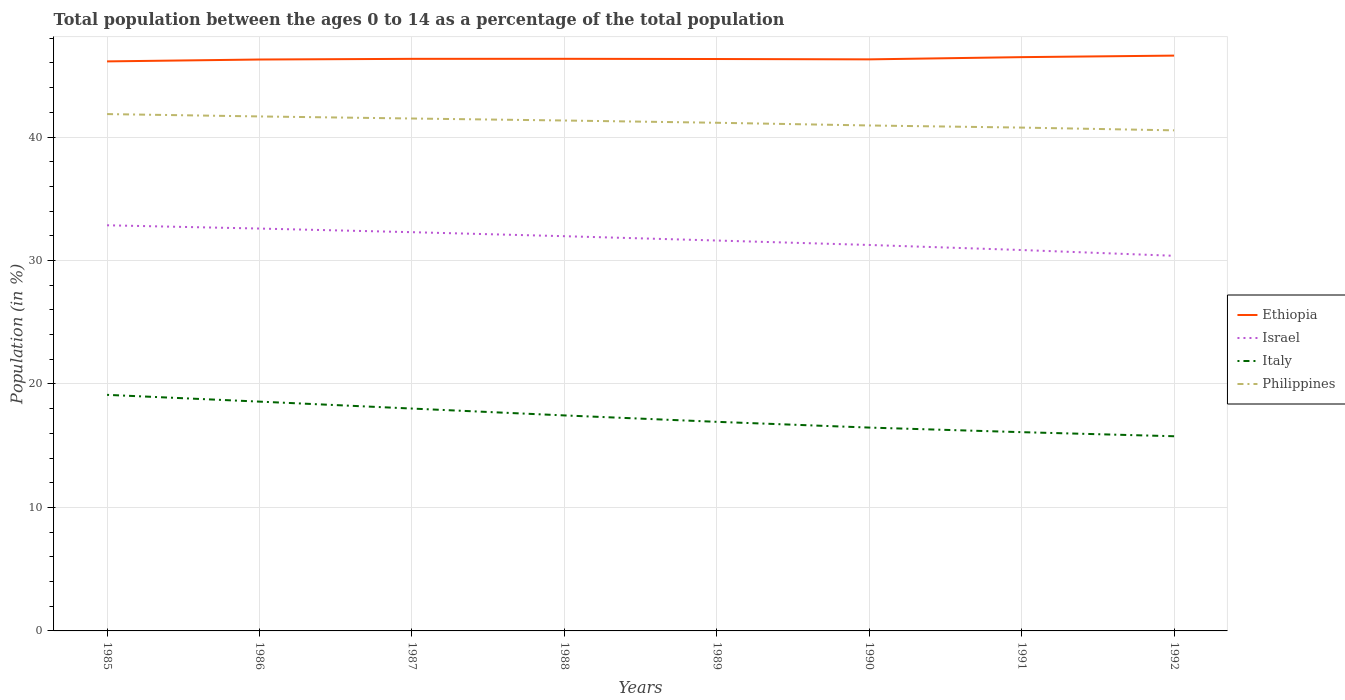Is the number of lines equal to the number of legend labels?
Keep it short and to the point. Yes. Across all years, what is the maximum percentage of the population ages 0 to 14 in Philippines?
Offer a terse response. 40.54. In which year was the percentage of the population ages 0 to 14 in Philippines maximum?
Give a very brief answer. 1992. What is the total percentage of the population ages 0 to 14 in Italy in the graph?
Provide a short and direct response. 2.1. What is the difference between the highest and the second highest percentage of the population ages 0 to 14 in Italy?
Provide a succinct answer. 3.35. What is the difference between the highest and the lowest percentage of the population ages 0 to 14 in Italy?
Provide a short and direct response. 4. How many lines are there?
Your answer should be compact. 4. Are the values on the major ticks of Y-axis written in scientific E-notation?
Your answer should be very brief. No. What is the title of the graph?
Offer a very short reply. Total population between the ages 0 to 14 as a percentage of the total population. Does "High income: OECD" appear as one of the legend labels in the graph?
Your answer should be very brief. No. What is the Population (in %) of Ethiopia in 1985?
Keep it short and to the point. 46.13. What is the Population (in %) in Israel in 1985?
Your response must be concise. 32.85. What is the Population (in %) of Italy in 1985?
Provide a short and direct response. 19.12. What is the Population (in %) of Philippines in 1985?
Provide a short and direct response. 41.86. What is the Population (in %) in Ethiopia in 1986?
Make the answer very short. 46.28. What is the Population (in %) in Israel in 1986?
Ensure brevity in your answer.  32.59. What is the Population (in %) of Italy in 1986?
Give a very brief answer. 18.57. What is the Population (in %) of Philippines in 1986?
Offer a terse response. 41.67. What is the Population (in %) in Ethiopia in 1987?
Your answer should be very brief. 46.34. What is the Population (in %) of Israel in 1987?
Provide a succinct answer. 32.3. What is the Population (in %) of Italy in 1987?
Your answer should be very brief. 18.01. What is the Population (in %) of Philippines in 1987?
Ensure brevity in your answer.  41.5. What is the Population (in %) in Ethiopia in 1988?
Keep it short and to the point. 46.34. What is the Population (in %) of Israel in 1988?
Your response must be concise. 31.97. What is the Population (in %) in Italy in 1988?
Your answer should be very brief. 17.45. What is the Population (in %) in Philippines in 1988?
Provide a succinct answer. 41.34. What is the Population (in %) in Ethiopia in 1989?
Provide a succinct answer. 46.32. What is the Population (in %) of Israel in 1989?
Offer a terse response. 31.62. What is the Population (in %) of Italy in 1989?
Your response must be concise. 16.94. What is the Population (in %) in Philippines in 1989?
Provide a short and direct response. 41.16. What is the Population (in %) in Ethiopia in 1990?
Offer a very short reply. 46.29. What is the Population (in %) of Israel in 1990?
Offer a terse response. 31.26. What is the Population (in %) of Italy in 1990?
Keep it short and to the point. 16.47. What is the Population (in %) in Philippines in 1990?
Your response must be concise. 40.94. What is the Population (in %) of Ethiopia in 1991?
Your answer should be compact. 46.47. What is the Population (in %) of Israel in 1991?
Keep it short and to the point. 30.85. What is the Population (in %) in Italy in 1991?
Ensure brevity in your answer.  16.1. What is the Population (in %) of Philippines in 1991?
Your response must be concise. 40.77. What is the Population (in %) of Ethiopia in 1992?
Provide a succinct answer. 46.6. What is the Population (in %) in Israel in 1992?
Provide a short and direct response. 30.38. What is the Population (in %) in Italy in 1992?
Offer a very short reply. 15.77. What is the Population (in %) in Philippines in 1992?
Give a very brief answer. 40.54. Across all years, what is the maximum Population (in %) in Ethiopia?
Provide a short and direct response. 46.6. Across all years, what is the maximum Population (in %) of Israel?
Give a very brief answer. 32.85. Across all years, what is the maximum Population (in %) of Italy?
Offer a very short reply. 19.12. Across all years, what is the maximum Population (in %) in Philippines?
Provide a succinct answer. 41.86. Across all years, what is the minimum Population (in %) in Ethiopia?
Your answer should be compact. 46.13. Across all years, what is the minimum Population (in %) in Israel?
Provide a succinct answer. 30.38. Across all years, what is the minimum Population (in %) of Italy?
Your answer should be very brief. 15.77. Across all years, what is the minimum Population (in %) of Philippines?
Your answer should be very brief. 40.54. What is the total Population (in %) of Ethiopia in the graph?
Provide a succinct answer. 370.77. What is the total Population (in %) of Israel in the graph?
Provide a succinct answer. 253.83. What is the total Population (in %) in Italy in the graph?
Provide a succinct answer. 138.43. What is the total Population (in %) of Philippines in the graph?
Provide a short and direct response. 329.79. What is the difference between the Population (in %) of Ethiopia in 1985 and that in 1986?
Ensure brevity in your answer.  -0.15. What is the difference between the Population (in %) in Israel in 1985 and that in 1986?
Ensure brevity in your answer.  0.27. What is the difference between the Population (in %) of Italy in 1985 and that in 1986?
Provide a short and direct response. 0.55. What is the difference between the Population (in %) of Philippines in 1985 and that in 1986?
Your answer should be compact. 0.19. What is the difference between the Population (in %) in Ethiopia in 1985 and that in 1987?
Your answer should be compact. -0.21. What is the difference between the Population (in %) of Israel in 1985 and that in 1987?
Your answer should be compact. 0.56. What is the difference between the Population (in %) in Italy in 1985 and that in 1987?
Give a very brief answer. 1.11. What is the difference between the Population (in %) of Philippines in 1985 and that in 1987?
Your answer should be compact. 0.36. What is the difference between the Population (in %) in Ethiopia in 1985 and that in 1988?
Your answer should be compact. -0.21. What is the difference between the Population (in %) in Israel in 1985 and that in 1988?
Your answer should be compact. 0.88. What is the difference between the Population (in %) of Italy in 1985 and that in 1988?
Provide a succinct answer. 1.67. What is the difference between the Population (in %) of Philippines in 1985 and that in 1988?
Your answer should be very brief. 0.52. What is the difference between the Population (in %) in Ethiopia in 1985 and that in 1989?
Keep it short and to the point. -0.19. What is the difference between the Population (in %) in Israel in 1985 and that in 1989?
Offer a very short reply. 1.23. What is the difference between the Population (in %) of Italy in 1985 and that in 1989?
Provide a short and direct response. 2.19. What is the difference between the Population (in %) in Philippines in 1985 and that in 1989?
Keep it short and to the point. 0.7. What is the difference between the Population (in %) of Ethiopia in 1985 and that in 1990?
Your response must be concise. -0.16. What is the difference between the Population (in %) of Israel in 1985 and that in 1990?
Give a very brief answer. 1.59. What is the difference between the Population (in %) in Italy in 1985 and that in 1990?
Make the answer very short. 2.65. What is the difference between the Population (in %) in Philippines in 1985 and that in 1990?
Ensure brevity in your answer.  0.92. What is the difference between the Population (in %) of Ethiopia in 1985 and that in 1991?
Make the answer very short. -0.34. What is the difference between the Population (in %) of Israel in 1985 and that in 1991?
Keep it short and to the point. 2. What is the difference between the Population (in %) in Italy in 1985 and that in 1991?
Your answer should be very brief. 3.02. What is the difference between the Population (in %) of Philippines in 1985 and that in 1991?
Your response must be concise. 1.09. What is the difference between the Population (in %) in Ethiopia in 1985 and that in 1992?
Ensure brevity in your answer.  -0.47. What is the difference between the Population (in %) in Israel in 1985 and that in 1992?
Keep it short and to the point. 2.47. What is the difference between the Population (in %) in Italy in 1985 and that in 1992?
Ensure brevity in your answer.  3.35. What is the difference between the Population (in %) of Philippines in 1985 and that in 1992?
Provide a short and direct response. 1.32. What is the difference between the Population (in %) of Ethiopia in 1986 and that in 1987?
Your answer should be very brief. -0.05. What is the difference between the Population (in %) of Israel in 1986 and that in 1987?
Offer a very short reply. 0.29. What is the difference between the Population (in %) in Italy in 1986 and that in 1987?
Offer a terse response. 0.56. What is the difference between the Population (in %) of Philippines in 1986 and that in 1987?
Your answer should be compact. 0.17. What is the difference between the Population (in %) in Ethiopia in 1986 and that in 1988?
Give a very brief answer. -0.06. What is the difference between the Population (in %) in Israel in 1986 and that in 1988?
Provide a succinct answer. 0.62. What is the difference between the Population (in %) of Italy in 1986 and that in 1988?
Make the answer very short. 1.12. What is the difference between the Population (in %) of Philippines in 1986 and that in 1988?
Your response must be concise. 0.33. What is the difference between the Population (in %) of Ethiopia in 1986 and that in 1989?
Provide a succinct answer. -0.04. What is the difference between the Population (in %) of Israel in 1986 and that in 1989?
Keep it short and to the point. 0.97. What is the difference between the Population (in %) in Italy in 1986 and that in 1989?
Make the answer very short. 1.64. What is the difference between the Population (in %) of Philippines in 1986 and that in 1989?
Your answer should be compact. 0.51. What is the difference between the Population (in %) in Ethiopia in 1986 and that in 1990?
Your answer should be compact. -0.01. What is the difference between the Population (in %) of Israel in 1986 and that in 1990?
Provide a short and direct response. 1.33. What is the difference between the Population (in %) of Italy in 1986 and that in 1990?
Make the answer very short. 2.1. What is the difference between the Population (in %) in Philippines in 1986 and that in 1990?
Your answer should be compact. 0.73. What is the difference between the Population (in %) in Ethiopia in 1986 and that in 1991?
Your response must be concise. -0.19. What is the difference between the Population (in %) in Israel in 1986 and that in 1991?
Offer a terse response. 1.74. What is the difference between the Population (in %) of Italy in 1986 and that in 1991?
Offer a very short reply. 2.47. What is the difference between the Population (in %) of Philippines in 1986 and that in 1991?
Provide a short and direct response. 0.9. What is the difference between the Population (in %) in Ethiopia in 1986 and that in 1992?
Your answer should be very brief. -0.32. What is the difference between the Population (in %) of Israel in 1986 and that in 1992?
Your response must be concise. 2.21. What is the difference between the Population (in %) of Italy in 1986 and that in 1992?
Your answer should be very brief. 2.8. What is the difference between the Population (in %) of Philippines in 1986 and that in 1992?
Your response must be concise. 1.13. What is the difference between the Population (in %) in Ethiopia in 1987 and that in 1988?
Offer a very short reply. -0. What is the difference between the Population (in %) in Israel in 1987 and that in 1988?
Make the answer very short. 0.33. What is the difference between the Population (in %) in Italy in 1987 and that in 1988?
Ensure brevity in your answer.  0.56. What is the difference between the Population (in %) in Philippines in 1987 and that in 1988?
Provide a succinct answer. 0.16. What is the difference between the Population (in %) of Ethiopia in 1987 and that in 1989?
Offer a terse response. 0.01. What is the difference between the Population (in %) in Israel in 1987 and that in 1989?
Your answer should be very brief. 0.68. What is the difference between the Population (in %) in Italy in 1987 and that in 1989?
Keep it short and to the point. 1.07. What is the difference between the Population (in %) of Philippines in 1987 and that in 1989?
Offer a terse response. 0.34. What is the difference between the Population (in %) of Ethiopia in 1987 and that in 1990?
Provide a short and direct response. 0.04. What is the difference between the Population (in %) of Israel in 1987 and that in 1990?
Your answer should be compact. 1.04. What is the difference between the Population (in %) of Italy in 1987 and that in 1990?
Keep it short and to the point. 1.54. What is the difference between the Population (in %) of Philippines in 1987 and that in 1990?
Ensure brevity in your answer.  0.56. What is the difference between the Population (in %) in Ethiopia in 1987 and that in 1991?
Provide a succinct answer. -0.14. What is the difference between the Population (in %) in Israel in 1987 and that in 1991?
Offer a very short reply. 1.45. What is the difference between the Population (in %) in Italy in 1987 and that in 1991?
Provide a succinct answer. 1.91. What is the difference between the Population (in %) in Philippines in 1987 and that in 1991?
Keep it short and to the point. 0.74. What is the difference between the Population (in %) in Ethiopia in 1987 and that in 1992?
Your answer should be compact. -0.26. What is the difference between the Population (in %) of Israel in 1987 and that in 1992?
Ensure brevity in your answer.  1.91. What is the difference between the Population (in %) of Italy in 1987 and that in 1992?
Your answer should be compact. 2.24. What is the difference between the Population (in %) in Philippines in 1987 and that in 1992?
Your answer should be very brief. 0.96. What is the difference between the Population (in %) of Ethiopia in 1988 and that in 1989?
Your answer should be very brief. 0.02. What is the difference between the Population (in %) of Israel in 1988 and that in 1989?
Give a very brief answer. 0.35. What is the difference between the Population (in %) of Italy in 1988 and that in 1989?
Your answer should be very brief. 0.52. What is the difference between the Population (in %) of Philippines in 1988 and that in 1989?
Offer a very short reply. 0.18. What is the difference between the Population (in %) in Ethiopia in 1988 and that in 1990?
Offer a terse response. 0.04. What is the difference between the Population (in %) in Israel in 1988 and that in 1990?
Offer a very short reply. 0.71. What is the difference between the Population (in %) of Italy in 1988 and that in 1990?
Your answer should be very brief. 0.99. What is the difference between the Population (in %) in Philippines in 1988 and that in 1990?
Your answer should be compact. 0.4. What is the difference between the Population (in %) in Ethiopia in 1988 and that in 1991?
Your answer should be very brief. -0.14. What is the difference between the Population (in %) of Israel in 1988 and that in 1991?
Offer a terse response. 1.12. What is the difference between the Population (in %) of Italy in 1988 and that in 1991?
Give a very brief answer. 1.36. What is the difference between the Population (in %) of Philippines in 1988 and that in 1991?
Offer a terse response. 0.57. What is the difference between the Population (in %) of Ethiopia in 1988 and that in 1992?
Provide a short and direct response. -0.26. What is the difference between the Population (in %) of Israel in 1988 and that in 1992?
Ensure brevity in your answer.  1.59. What is the difference between the Population (in %) of Italy in 1988 and that in 1992?
Give a very brief answer. 1.69. What is the difference between the Population (in %) of Philippines in 1988 and that in 1992?
Your answer should be compact. 0.8. What is the difference between the Population (in %) in Ethiopia in 1989 and that in 1990?
Offer a very short reply. 0.03. What is the difference between the Population (in %) in Israel in 1989 and that in 1990?
Your response must be concise. 0.36. What is the difference between the Population (in %) of Italy in 1989 and that in 1990?
Your answer should be very brief. 0.47. What is the difference between the Population (in %) of Philippines in 1989 and that in 1990?
Give a very brief answer. 0.22. What is the difference between the Population (in %) in Ethiopia in 1989 and that in 1991?
Make the answer very short. -0.15. What is the difference between the Population (in %) in Israel in 1989 and that in 1991?
Give a very brief answer. 0.77. What is the difference between the Population (in %) of Italy in 1989 and that in 1991?
Give a very brief answer. 0.84. What is the difference between the Population (in %) of Philippines in 1989 and that in 1991?
Your response must be concise. 0.39. What is the difference between the Population (in %) in Ethiopia in 1989 and that in 1992?
Your answer should be very brief. -0.28. What is the difference between the Population (in %) of Israel in 1989 and that in 1992?
Ensure brevity in your answer.  1.24. What is the difference between the Population (in %) in Italy in 1989 and that in 1992?
Provide a short and direct response. 1.17. What is the difference between the Population (in %) in Philippines in 1989 and that in 1992?
Offer a very short reply. 0.61. What is the difference between the Population (in %) of Ethiopia in 1990 and that in 1991?
Provide a short and direct response. -0.18. What is the difference between the Population (in %) in Israel in 1990 and that in 1991?
Your answer should be very brief. 0.41. What is the difference between the Population (in %) of Italy in 1990 and that in 1991?
Give a very brief answer. 0.37. What is the difference between the Population (in %) of Philippines in 1990 and that in 1991?
Keep it short and to the point. 0.17. What is the difference between the Population (in %) in Ethiopia in 1990 and that in 1992?
Make the answer very short. -0.3. What is the difference between the Population (in %) of Israel in 1990 and that in 1992?
Make the answer very short. 0.88. What is the difference between the Population (in %) of Italy in 1990 and that in 1992?
Your answer should be very brief. 0.7. What is the difference between the Population (in %) of Philippines in 1990 and that in 1992?
Keep it short and to the point. 0.4. What is the difference between the Population (in %) of Ethiopia in 1991 and that in 1992?
Provide a succinct answer. -0.12. What is the difference between the Population (in %) in Israel in 1991 and that in 1992?
Ensure brevity in your answer.  0.47. What is the difference between the Population (in %) of Italy in 1991 and that in 1992?
Make the answer very short. 0.33. What is the difference between the Population (in %) of Philippines in 1991 and that in 1992?
Offer a terse response. 0.22. What is the difference between the Population (in %) in Ethiopia in 1985 and the Population (in %) in Israel in 1986?
Your answer should be very brief. 13.54. What is the difference between the Population (in %) of Ethiopia in 1985 and the Population (in %) of Italy in 1986?
Offer a terse response. 27.56. What is the difference between the Population (in %) of Ethiopia in 1985 and the Population (in %) of Philippines in 1986?
Your answer should be very brief. 4.46. What is the difference between the Population (in %) of Israel in 1985 and the Population (in %) of Italy in 1986?
Provide a short and direct response. 14.28. What is the difference between the Population (in %) of Israel in 1985 and the Population (in %) of Philippines in 1986?
Offer a terse response. -8.82. What is the difference between the Population (in %) of Italy in 1985 and the Population (in %) of Philippines in 1986?
Your response must be concise. -22.55. What is the difference between the Population (in %) of Ethiopia in 1985 and the Population (in %) of Israel in 1987?
Ensure brevity in your answer.  13.83. What is the difference between the Population (in %) of Ethiopia in 1985 and the Population (in %) of Italy in 1987?
Keep it short and to the point. 28.12. What is the difference between the Population (in %) in Ethiopia in 1985 and the Population (in %) in Philippines in 1987?
Your response must be concise. 4.63. What is the difference between the Population (in %) of Israel in 1985 and the Population (in %) of Italy in 1987?
Offer a terse response. 14.84. What is the difference between the Population (in %) in Israel in 1985 and the Population (in %) in Philippines in 1987?
Make the answer very short. -8.65. What is the difference between the Population (in %) of Italy in 1985 and the Population (in %) of Philippines in 1987?
Your response must be concise. -22.38. What is the difference between the Population (in %) in Ethiopia in 1985 and the Population (in %) in Israel in 1988?
Provide a succinct answer. 14.16. What is the difference between the Population (in %) in Ethiopia in 1985 and the Population (in %) in Italy in 1988?
Your response must be concise. 28.67. What is the difference between the Population (in %) of Ethiopia in 1985 and the Population (in %) of Philippines in 1988?
Provide a succinct answer. 4.79. What is the difference between the Population (in %) of Israel in 1985 and the Population (in %) of Italy in 1988?
Provide a succinct answer. 15.4. What is the difference between the Population (in %) in Israel in 1985 and the Population (in %) in Philippines in 1988?
Offer a very short reply. -8.49. What is the difference between the Population (in %) in Italy in 1985 and the Population (in %) in Philippines in 1988?
Keep it short and to the point. -22.22. What is the difference between the Population (in %) of Ethiopia in 1985 and the Population (in %) of Israel in 1989?
Offer a terse response. 14.51. What is the difference between the Population (in %) in Ethiopia in 1985 and the Population (in %) in Italy in 1989?
Keep it short and to the point. 29.19. What is the difference between the Population (in %) in Ethiopia in 1985 and the Population (in %) in Philippines in 1989?
Give a very brief answer. 4.97. What is the difference between the Population (in %) in Israel in 1985 and the Population (in %) in Italy in 1989?
Ensure brevity in your answer.  15.92. What is the difference between the Population (in %) of Israel in 1985 and the Population (in %) of Philippines in 1989?
Provide a succinct answer. -8.3. What is the difference between the Population (in %) in Italy in 1985 and the Population (in %) in Philippines in 1989?
Make the answer very short. -22.04. What is the difference between the Population (in %) in Ethiopia in 1985 and the Population (in %) in Israel in 1990?
Offer a very short reply. 14.87. What is the difference between the Population (in %) in Ethiopia in 1985 and the Population (in %) in Italy in 1990?
Give a very brief answer. 29.66. What is the difference between the Population (in %) of Ethiopia in 1985 and the Population (in %) of Philippines in 1990?
Keep it short and to the point. 5.19. What is the difference between the Population (in %) in Israel in 1985 and the Population (in %) in Italy in 1990?
Keep it short and to the point. 16.39. What is the difference between the Population (in %) of Israel in 1985 and the Population (in %) of Philippines in 1990?
Offer a terse response. -8.08. What is the difference between the Population (in %) of Italy in 1985 and the Population (in %) of Philippines in 1990?
Your answer should be compact. -21.82. What is the difference between the Population (in %) of Ethiopia in 1985 and the Population (in %) of Israel in 1991?
Your answer should be very brief. 15.28. What is the difference between the Population (in %) in Ethiopia in 1985 and the Population (in %) in Italy in 1991?
Keep it short and to the point. 30.03. What is the difference between the Population (in %) in Ethiopia in 1985 and the Population (in %) in Philippines in 1991?
Give a very brief answer. 5.36. What is the difference between the Population (in %) in Israel in 1985 and the Population (in %) in Italy in 1991?
Ensure brevity in your answer.  16.76. What is the difference between the Population (in %) in Israel in 1985 and the Population (in %) in Philippines in 1991?
Offer a terse response. -7.91. What is the difference between the Population (in %) of Italy in 1985 and the Population (in %) of Philippines in 1991?
Your answer should be compact. -21.65. What is the difference between the Population (in %) of Ethiopia in 1985 and the Population (in %) of Israel in 1992?
Make the answer very short. 15.75. What is the difference between the Population (in %) in Ethiopia in 1985 and the Population (in %) in Italy in 1992?
Offer a very short reply. 30.36. What is the difference between the Population (in %) in Ethiopia in 1985 and the Population (in %) in Philippines in 1992?
Your response must be concise. 5.59. What is the difference between the Population (in %) in Israel in 1985 and the Population (in %) in Italy in 1992?
Give a very brief answer. 17.09. What is the difference between the Population (in %) of Israel in 1985 and the Population (in %) of Philippines in 1992?
Provide a short and direct response. -7.69. What is the difference between the Population (in %) of Italy in 1985 and the Population (in %) of Philippines in 1992?
Provide a succinct answer. -21.42. What is the difference between the Population (in %) of Ethiopia in 1986 and the Population (in %) of Israel in 1987?
Your response must be concise. 13.98. What is the difference between the Population (in %) in Ethiopia in 1986 and the Population (in %) in Italy in 1987?
Ensure brevity in your answer.  28.27. What is the difference between the Population (in %) of Ethiopia in 1986 and the Population (in %) of Philippines in 1987?
Ensure brevity in your answer.  4.78. What is the difference between the Population (in %) in Israel in 1986 and the Population (in %) in Italy in 1987?
Offer a very short reply. 14.58. What is the difference between the Population (in %) of Israel in 1986 and the Population (in %) of Philippines in 1987?
Your answer should be very brief. -8.91. What is the difference between the Population (in %) of Italy in 1986 and the Population (in %) of Philippines in 1987?
Offer a very short reply. -22.93. What is the difference between the Population (in %) of Ethiopia in 1986 and the Population (in %) of Israel in 1988?
Make the answer very short. 14.31. What is the difference between the Population (in %) in Ethiopia in 1986 and the Population (in %) in Italy in 1988?
Provide a succinct answer. 28.83. What is the difference between the Population (in %) of Ethiopia in 1986 and the Population (in %) of Philippines in 1988?
Provide a short and direct response. 4.94. What is the difference between the Population (in %) of Israel in 1986 and the Population (in %) of Italy in 1988?
Your answer should be compact. 15.13. What is the difference between the Population (in %) of Israel in 1986 and the Population (in %) of Philippines in 1988?
Give a very brief answer. -8.75. What is the difference between the Population (in %) of Italy in 1986 and the Population (in %) of Philippines in 1988?
Ensure brevity in your answer.  -22.77. What is the difference between the Population (in %) in Ethiopia in 1986 and the Population (in %) in Israel in 1989?
Provide a short and direct response. 14.66. What is the difference between the Population (in %) in Ethiopia in 1986 and the Population (in %) in Italy in 1989?
Ensure brevity in your answer.  29.34. What is the difference between the Population (in %) in Ethiopia in 1986 and the Population (in %) in Philippines in 1989?
Keep it short and to the point. 5.12. What is the difference between the Population (in %) of Israel in 1986 and the Population (in %) of Italy in 1989?
Offer a terse response. 15.65. What is the difference between the Population (in %) of Israel in 1986 and the Population (in %) of Philippines in 1989?
Ensure brevity in your answer.  -8.57. What is the difference between the Population (in %) in Italy in 1986 and the Population (in %) in Philippines in 1989?
Provide a succinct answer. -22.59. What is the difference between the Population (in %) of Ethiopia in 1986 and the Population (in %) of Israel in 1990?
Ensure brevity in your answer.  15.02. What is the difference between the Population (in %) of Ethiopia in 1986 and the Population (in %) of Italy in 1990?
Your answer should be compact. 29.81. What is the difference between the Population (in %) of Ethiopia in 1986 and the Population (in %) of Philippines in 1990?
Give a very brief answer. 5.34. What is the difference between the Population (in %) in Israel in 1986 and the Population (in %) in Italy in 1990?
Make the answer very short. 16.12. What is the difference between the Population (in %) in Israel in 1986 and the Population (in %) in Philippines in 1990?
Keep it short and to the point. -8.35. What is the difference between the Population (in %) of Italy in 1986 and the Population (in %) of Philippines in 1990?
Give a very brief answer. -22.37. What is the difference between the Population (in %) of Ethiopia in 1986 and the Population (in %) of Israel in 1991?
Provide a short and direct response. 15.43. What is the difference between the Population (in %) in Ethiopia in 1986 and the Population (in %) in Italy in 1991?
Make the answer very short. 30.18. What is the difference between the Population (in %) of Ethiopia in 1986 and the Population (in %) of Philippines in 1991?
Make the answer very short. 5.51. What is the difference between the Population (in %) in Israel in 1986 and the Population (in %) in Italy in 1991?
Your answer should be compact. 16.49. What is the difference between the Population (in %) in Israel in 1986 and the Population (in %) in Philippines in 1991?
Offer a terse response. -8.18. What is the difference between the Population (in %) of Italy in 1986 and the Population (in %) of Philippines in 1991?
Your answer should be very brief. -22.2. What is the difference between the Population (in %) in Ethiopia in 1986 and the Population (in %) in Israel in 1992?
Provide a short and direct response. 15.9. What is the difference between the Population (in %) in Ethiopia in 1986 and the Population (in %) in Italy in 1992?
Your answer should be very brief. 30.51. What is the difference between the Population (in %) in Ethiopia in 1986 and the Population (in %) in Philippines in 1992?
Offer a terse response. 5.74. What is the difference between the Population (in %) of Israel in 1986 and the Population (in %) of Italy in 1992?
Give a very brief answer. 16.82. What is the difference between the Population (in %) in Israel in 1986 and the Population (in %) in Philippines in 1992?
Give a very brief answer. -7.95. What is the difference between the Population (in %) in Italy in 1986 and the Population (in %) in Philippines in 1992?
Your response must be concise. -21.97. What is the difference between the Population (in %) in Ethiopia in 1987 and the Population (in %) in Israel in 1988?
Give a very brief answer. 14.36. What is the difference between the Population (in %) of Ethiopia in 1987 and the Population (in %) of Italy in 1988?
Provide a short and direct response. 28.88. What is the difference between the Population (in %) in Ethiopia in 1987 and the Population (in %) in Philippines in 1988?
Offer a very short reply. 4.99. What is the difference between the Population (in %) of Israel in 1987 and the Population (in %) of Italy in 1988?
Make the answer very short. 14.84. What is the difference between the Population (in %) of Israel in 1987 and the Population (in %) of Philippines in 1988?
Your answer should be very brief. -9.05. What is the difference between the Population (in %) of Italy in 1987 and the Population (in %) of Philippines in 1988?
Your response must be concise. -23.33. What is the difference between the Population (in %) in Ethiopia in 1987 and the Population (in %) in Israel in 1989?
Keep it short and to the point. 14.71. What is the difference between the Population (in %) of Ethiopia in 1987 and the Population (in %) of Italy in 1989?
Offer a very short reply. 29.4. What is the difference between the Population (in %) in Ethiopia in 1987 and the Population (in %) in Philippines in 1989?
Make the answer very short. 5.18. What is the difference between the Population (in %) in Israel in 1987 and the Population (in %) in Italy in 1989?
Your answer should be compact. 15.36. What is the difference between the Population (in %) of Israel in 1987 and the Population (in %) of Philippines in 1989?
Offer a terse response. -8.86. What is the difference between the Population (in %) of Italy in 1987 and the Population (in %) of Philippines in 1989?
Your answer should be compact. -23.15. What is the difference between the Population (in %) in Ethiopia in 1987 and the Population (in %) in Israel in 1990?
Offer a very short reply. 15.07. What is the difference between the Population (in %) in Ethiopia in 1987 and the Population (in %) in Italy in 1990?
Offer a very short reply. 29.87. What is the difference between the Population (in %) in Ethiopia in 1987 and the Population (in %) in Philippines in 1990?
Ensure brevity in your answer.  5.4. What is the difference between the Population (in %) of Israel in 1987 and the Population (in %) of Italy in 1990?
Make the answer very short. 15.83. What is the difference between the Population (in %) in Israel in 1987 and the Population (in %) in Philippines in 1990?
Give a very brief answer. -8.64. What is the difference between the Population (in %) in Italy in 1987 and the Population (in %) in Philippines in 1990?
Ensure brevity in your answer.  -22.93. What is the difference between the Population (in %) of Ethiopia in 1987 and the Population (in %) of Israel in 1991?
Ensure brevity in your answer.  15.48. What is the difference between the Population (in %) in Ethiopia in 1987 and the Population (in %) in Italy in 1991?
Make the answer very short. 30.24. What is the difference between the Population (in %) of Ethiopia in 1987 and the Population (in %) of Philippines in 1991?
Make the answer very short. 5.57. What is the difference between the Population (in %) in Israel in 1987 and the Population (in %) in Italy in 1991?
Your answer should be very brief. 16.2. What is the difference between the Population (in %) in Israel in 1987 and the Population (in %) in Philippines in 1991?
Provide a short and direct response. -8.47. What is the difference between the Population (in %) of Italy in 1987 and the Population (in %) of Philippines in 1991?
Your answer should be compact. -22.76. What is the difference between the Population (in %) in Ethiopia in 1987 and the Population (in %) in Israel in 1992?
Make the answer very short. 15.95. What is the difference between the Population (in %) in Ethiopia in 1987 and the Population (in %) in Italy in 1992?
Offer a very short reply. 30.57. What is the difference between the Population (in %) in Ethiopia in 1987 and the Population (in %) in Philippines in 1992?
Your response must be concise. 5.79. What is the difference between the Population (in %) in Israel in 1987 and the Population (in %) in Italy in 1992?
Offer a very short reply. 16.53. What is the difference between the Population (in %) of Israel in 1987 and the Population (in %) of Philippines in 1992?
Offer a terse response. -8.25. What is the difference between the Population (in %) in Italy in 1987 and the Population (in %) in Philippines in 1992?
Provide a short and direct response. -22.53. What is the difference between the Population (in %) of Ethiopia in 1988 and the Population (in %) of Israel in 1989?
Make the answer very short. 14.72. What is the difference between the Population (in %) of Ethiopia in 1988 and the Population (in %) of Italy in 1989?
Offer a very short reply. 29.4. What is the difference between the Population (in %) in Ethiopia in 1988 and the Population (in %) in Philippines in 1989?
Your response must be concise. 5.18. What is the difference between the Population (in %) of Israel in 1988 and the Population (in %) of Italy in 1989?
Your answer should be compact. 15.04. What is the difference between the Population (in %) of Israel in 1988 and the Population (in %) of Philippines in 1989?
Your answer should be compact. -9.19. What is the difference between the Population (in %) in Italy in 1988 and the Population (in %) in Philippines in 1989?
Provide a short and direct response. -23.7. What is the difference between the Population (in %) of Ethiopia in 1988 and the Population (in %) of Israel in 1990?
Offer a very short reply. 15.08. What is the difference between the Population (in %) in Ethiopia in 1988 and the Population (in %) in Italy in 1990?
Offer a terse response. 29.87. What is the difference between the Population (in %) in Ethiopia in 1988 and the Population (in %) in Philippines in 1990?
Your answer should be compact. 5.4. What is the difference between the Population (in %) in Israel in 1988 and the Population (in %) in Italy in 1990?
Offer a terse response. 15.5. What is the difference between the Population (in %) of Israel in 1988 and the Population (in %) of Philippines in 1990?
Ensure brevity in your answer.  -8.97. What is the difference between the Population (in %) in Italy in 1988 and the Population (in %) in Philippines in 1990?
Your response must be concise. -23.48. What is the difference between the Population (in %) of Ethiopia in 1988 and the Population (in %) of Israel in 1991?
Provide a short and direct response. 15.49. What is the difference between the Population (in %) in Ethiopia in 1988 and the Population (in %) in Italy in 1991?
Your response must be concise. 30.24. What is the difference between the Population (in %) of Ethiopia in 1988 and the Population (in %) of Philippines in 1991?
Your answer should be very brief. 5.57. What is the difference between the Population (in %) in Israel in 1988 and the Population (in %) in Italy in 1991?
Provide a succinct answer. 15.87. What is the difference between the Population (in %) of Israel in 1988 and the Population (in %) of Philippines in 1991?
Provide a succinct answer. -8.8. What is the difference between the Population (in %) of Italy in 1988 and the Population (in %) of Philippines in 1991?
Offer a terse response. -23.31. What is the difference between the Population (in %) in Ethiopia in 1988 and the Population (in %) in Israel in 1992?
Offer a terse response. 15.95. What is the difference between the Population (in %) of Ethiopia in 1988 and the Population (in %) of Italy in 1992?
Provide a succinct answer. 30.57. What is the difference between the Population (in %) in Ethiopia in 1988 and the Population (in %) in Philippines in 1992?
Your response must be concise. 5.79. What is the difference between the Population (in %) of Israel in 1988 and the Population (in %) of Italy in 1992?
Provide a succinct answer. 16.2. What is the difference between the Population (in %) of Israel in 1988 and the Population (in %) of Philippines in 1992?
Give a very brief answer. -8.57. What is the difference between the Population (in %) in Italy in 1988 and the Population (in %) in Philippines in 1992?
Provide a succinct answer. -23.09. What is the difference between the Population (in %) in Ethiopia in 1989 and the Population (in %) in Israel in 1990?
Offer a terse response. 15.06. What is the difference between the Population (in %) in Ethiopia in 1989 and the Population (in %) in Italy in 1990?
Your answer should be very brief. 29.85. What is the difference between the Population (in %) of Ethiopia in 1989 and the Population (in %) of Philippines in 1990?
Your answer should be very brief. 5.38. What is the difference between the Population (in %) in Israel in 1989 and the Population (in %) in Italy in 1990?
Give a very brief answer. 15.15. What is the difference between the Population (in %) in Israel in 1989 and the Population (in %) in Philippines in 1990?
Make the answer very short. -9.32. What is the difference between the Population (in %) in Italy in 1989 and the Population (in %) in Philippines in 1990?
Provide a short and direct response. -24. What is the difference between the Population (in %) of Ethiopia in 1989 and the Population (in %) of Israel in 1991?
Make the answer very short. 15.47. What is the difference between the Population (in %) of Ethiopia in 1989 and the Population (in %) of Italy in 1991?
Offer a terse response. 30.22. What is the difference between the Population (in %) in Ethiopia in 1989 and the Population (in %) in Philippines in 1991?
Keep it short and to the point. 5.55. What is the difference between the Population (in %) in Israel in 1989 and the Population (in %) in Italy in 1991?
Ensure brevity in your answer.  15.52. What is the difference between the Population (in %) in Israel in 1989 and the Population (in %) in Philippines in 1991?
Provide a short and direct response. -9.15. What is the difference between the Population (in %) in Italy in 1989 and the Population (in %) in Philippines in 1991?
Ensure brevity in your answer.  -23.83. What is the difference between the Population (in %) in Ethiopia in 1989 and the Population (in %) in Israel in 1992?
Your answer should be very brief. 15.94. What is the difference between the Population (in %) in Ethiopia in 1989 and the Population (in %) in Italy in 1992?
Keep it short and to the point. 30.55. What is the difference between the Population (in %) in Ethiopia in 1989 and the Population (in %) in Philippines in 1992?
Your answer should be compact. 5.78. What is the difference between the Population (in %) in Israel in 1989 and the Population (in %) in Italy in 1992?
Offer a very short reply. 15.85. What is the difference between the Population (in %) in Israel in 1989 and the Population (in %) in Philippines in 1992?
Offer a terse response. -8.92. What is the difference between the Population (in %) in Italy in 1989 and the Population (in %) in Philippines in 1992?
Your answer should be very brief. -23.61. What is the difference between the Population (in %) of Ethiopia in 1990 and the Population (in %) of Israel in 1991?
Offer a terse response. 15.44. What is the difference between the Population (in %) of Ethiopia in 1990 and the Population (in %) of Italy in 1991?
Ensure brevity in your answer.  30.2. What is the difference between the Population (in %) in Ethiopia in 1990 and the Population (in %) in Philippines in 1991?
Keep it short and to the point. 5.53. What is the difference between the Population (in %) in Israel in 1990 and the Population (in %) in Italy in 1991?
Provide a short and direct response. 15.16. What is the difference between the Population (in %) in Israel in 1990 and the Population (in %) in Philippines in 1991?
Give a very brief answer. -9.51. What is the difference between the Population (in %) in Italy in 1990 and the Population (in %) in Philippines in 1991?
Give a very brief answer. -24.3. What is the difference between the Population (in %) in Ethiopia in 1990 and the Population (in %) in Israel in 1992?
Provide a short and direct response. 15.91. What is the difference between the Population (in %) in Ethiopia in 1990 and the Population (in %) in Italy in 1992?
Your response must be concise. 30.53. What is the difference between the Population (in %) of Ethiopia in 1990 and the Population (in %) of Philippines in 1992?
Offer a terse response. 5.75. What is the difference between the Population (in %) of Israel in 1990 and the Population (in %) of Italy in 1992?
Offer a very short reply. 15.49. What is the difference between the Population (in %) in Israel in 1990 and the Population (in %) in Philippines in 1992?
Keep it short and to the point. -9.28. What is the difference between the Population (in %) in Italy in 1990 and the Population (in %) in Philippines in 1992?
Offer a terse response. -24.07. What is the difference between the Population (in %) in Ethiopia in 1991 and the Population (in %) in Israel in 1992?
Your answer should be compact. 16.09. What is the difference between the Population (in %) in Ethiopia in 1991 and the Population (in %) in Italy in 1992?
Your answer should be compact. 30.71. What is the difference between the Population (in %) of Ethiopia in 1991 and the Population (in %) of Philippines in 1992?
Your answer should be very brief. 5.93. What is the difference between the Population (in %) in Israel in 1991 and the Population (in %) in Italy in 1992?
Provide a short and direct response. 15.08. What is the difference between the Population (in %) in Israel in 1991 and the Population (in %) in Philippines in 1992?
Ensure brevity in your answer.  -9.69. What is the difference between the Population (in %) of Italy in 1991 and the Population (in %) of Philippines in 1992?
Your answer should be compact. -24.45. What is the average Population (in %) in Ethiopia per year?
Make the answer very short. 46.35. What is the average Population (in %) of Israel per year?
Offer a very short reply. 31.73. What is the average Population (in %) of Italy per year?
Your answer should be very brief. 17.3. What is the average Population (in %) in Philippines per year?
Your answer should be compact. 41.22. In the year 1985, what is the difference between the Population (in %) in Ethiopia and Population (in %) in Israel?
Make the answer very short. 13.27. In the year 1985, what is the difference between the Population (in %) in Ethiopia and Population (in %) in Italy?
Your answer should be compact. 27.01. In the year 1985, what is the difference between the Population (in %) in Ethiopia and Population (in %) in Philippines?
Offer a very short reply. 4.27. In the year 1985, what is the difference between the Population (in %) in Israel and Population (in %) in Italy?
Ensure brevity in your answer.  13.73. In the year 1985, what is the difference between the Population (in %) of Israel and Population (in %) of Philippines?
Your response must be concise. -9.01. In the year 1985, what is the difference between the Population (in %) of Italy and Population (in %) of Philippines?
Make the answer very short. -22.74. In the year 1986, what is the difference between the Population (in %) of Ethiopia and Population (in %) of Israel?
Your response must be concise. 13.69. In the year 1986, what is the difference between the Population (in %) of Ethiopia and Population (in %) of Italy?
Provide a short and direct response. 27.71. In the year 1986, what is the difference between the Population (in %) in Ethiopia and Population (in %) in Philippines?
Make the answer very short. 4.61. In the year 1986, what is the difference between the Population (in %) in Israel and Population (in %) in Italy?
Give a very brief answer. 14.02. In the year 1986, what is the difference between the Population (in %) in Israel and Population (in %) in Philippines?
Keep it short and to the point. -9.08. In the year 1986, what is the difference between the Population (in %) in Italy and Population (in %) in Philippines?
Provide a succinct answer. -23.1. In the year 1987, what is the difference between the Population (in %) in Ethiopia and Population (in %) in Israel?
Provide a short and direct response. 14.04. In the year 1987, what is the difference between the Population (in %) of Ethiopia and Population (in %) of Italy?
Offer a very short reply. 28.32. In the year 1987, what is the difference between the Population (in %) in Ethiopia and Population (in %) in Philippines?
Your response must be concise. 4.83. In the year 1987, what is the difference between the Population (in %) of Israel and Population (in %) of Italy?
Provide a short and direct response. 14.29. In the year 1987, what is the difference between the Population (in %) in Israel and Population (in %) in Philippines?
Offer a terse response. -9.21. In the year 1987, what is the difference between the Population (in %) of Italy and Population (in %) of Philippines?
Keep it short and to the point. -23.49. In the year 1988, what is the difference between the Population (in %) in Ethiopia and Population (in %) in Israel?
Your response must be concise. 14.37. In the year 1988, what is the difference between the Population (in %) of Ethiopia and Population (in %) of Italy?
Your response must be concise. 28.88. In the year 1988, what is the difference between the Population (in %) of Ethiopia and Population (in %) of Philippines?
Provide a succinct answer. 5. In the year 1988, what is the difference between the Population (in %) in Israel and Population (in %) in Italy?
Your answer should be very brief. 14.52. In the year 1988, what is the difference between the Population (in %) of Israel and Population (in %) of Philippines?
Offer a very short reply. -9.37. In the year 1988, what is the difference between the Population (in %) of Italy and Population (in %) of Philippines?
Keep it short and to the point. -23.89. In the year 1989, what is the difference between the Population (in %) of Ethiopia and Population (in %) of Israel?
Your answer should be compact. 14.7. In the year 1989, what is the difference between the Population (in %) in Ethiopia and Population (in %) in Italy?
Provide a short and direct response. 29.39. In the year 1989, what is the difference between the Population (in %) in Ethiopia and Population (in %) in Philippines?
Your answer should be compact. 5.16. In the year 1989, what is the difference between the Population (in %) in Israel and Population (in %) in Italy?
Keep it short and to the point. 14.69. In the year 1989, what is the difference between the Population (in %) in Israel and Population (in %) in Philippines?
Give a very brief answer. -9.54. In the year 1989, what is the difference between the Population (in %) in Italy and Population (in %) in Philippines?
Offer a very short reply. -24.22. In the year 1990, what is the difference between the Population (in %) in Ethiopia and Population (in %) in Israel?
Keep it short and to the point. 15.03. In the year 1990, what is the difference between the Population (in %) of Ethiopia and Population (in %) of Italy?
Ensure brevity in your answer.  29.82. In the year 1990, what is the difference between the Population (in %) of Ethiopia and Population (in %) of Philippines?
Give a very brief answer. 5.35. In the year 1990, what is the difference between the Population (in %) of Israel and Population (in %) of Italy?
Your response must be concise. 14.79. In the year 1990, what is the difference between the Population (in %) of Israel and Population (in %) of Philippines?
Your answer should be compact. -9.68. In the year 1990, what is the difference between the Population (in %) in Italy and Population (in %) in Philippines?
Your answer should be compact. -24.47. In the year 1991, what is the difference between the Population (in %) of Ethiopia and Population (in %) of Israel?
Ensure brevity in your answer.  15.62. In the year 1991, what is the difference between the Population (in %) of Ethiopia and Population (in %) of Italy?
Your response must be concise. 30.38. In the year 1991, what is the difference between the Population (in %) of Ethiopia and Population (in %) of Philippines?
Ensure brevity in your answer.  5.71. In the year 1991, what is the difference between the Population (in %) of Israel and Population (in %) of Italy?
Provide a succinct answer. 14.75. In the year 1991, what is the difference between the Population (in %) of Israel and Population (in %) of Philippines?
Offer a terse response. -9.92. In the year 1991, what is the difference between the Population (in %) of Italy and Population (in %) of Philippines?
Ensure brevity in your answer.  -24.67. In the year 1992, what is the difference between the Population (in %) in Ethiopia and Population (in %) in Israel?
Offer a terse response. 16.21. In the year 1992, what is the difference between the Population (in %) of Ethiopia and Population (in %) of Italy?
Offer a very short reply. 30.83. In the year 1992, what is the difference between the Population (in %) of Ethiopia and Population (in %) of Philippines?
Offer a very short reply. 6.05. In the year 1992, what is the difference between the Population (in %) in Israel and Population (in %) in Italy?
Provide a succinct answer. 14.62. In the year 1992, what is the difference between the Population (in %) of Israel and Population (in %) of Philippines?
Keep it short and to the point. -10.16. In the year 1992, what is the difference between the Population (in %) in Italy and Population (in %) in Philippines?
Keep it short and to the point. -24.78. What is the ratio of the Population (in %) of Ethiopia in 1985 to that in 1986?
Provide a succinct answer. 1. What is the ratio of the Population (in %) in Italy in 1985 to that in 1986?
Offer a terse response. 1.03. What is the ratio of the Population (in %) in Ethiopia in 1985 to that in 1987?
Your answer should be very brief. 1. What is the ratio of the Population (in %) of Israel in 1985 to that in 1987?
Keep it short and to the point. 1.02. What is the ratio of the Population (in %) in Italy in 1985 to that in 1987?
Your answer should be very brief. 1.06. What is the ratio of the Population (in %) of Philippines in 1985 to that in 1987?
Provide a short and direct response. 1.01. What is the ratio of the Population (in %) in Ethiopia in 1985 to that in 1988?
Your response must be concise. 1. What is the ratio of the Population (in %) of Israel in 1985 to that in 1988?
Ensure brevity in your answer.  1.03. What is the ratio of the Population (in %) in Italy in 1985 to that in 1988?
Your answer should be very brief. 1.1. What is the ratio of the Population (in %) of Philippines in 1985 to that in 1988?
Give a very brief answer. 1.01. What is the ratio of the Population (in %) in Israel in 1985 to that in 1989?
Offer a terse response. 1.04. What is the ratio of the Population (in %) of Italy in 1985 to that in 1989?
Offer a terse response. 1.13. What is the ratio of the Population (in %) in Philippines in 1985 to that in 1989?
Give a very brief answer. 1.02. What is the ratio of the Population (in %) in Ethiopia in 1985 to that in 1990?
Your answer should be very brief. 1. What is the ratio of the Population (in %) in Israel in 1985 to that in 1990?
Ensure brevity in your answer.  1.05. What is the ratio of the Population (in %) in Italy in 1985 to that in 1990?
Your answer should be very brief. 1.16. What is the ratio of the Population (in %) in Philippines in 1985 to that in 1990?
Your response must be concise. 1.02. What is the ratio of the Population (in %) in Ethiopia in 1985 to that in 1991?
Ensure brevity in your answer.  0.99. What is the ratio of the Population (in %) in Israel in 1985 to that in 1991?
Offer a very short reply. 1.06. What is the ratio of the Population (in %) in Italy in 1985 to that in 1991?
Your response must be concise. 1.19. What is the ratio of the Population (in %) of Philippines in 1985 to that in 1991?
Your answer should be compact. 1.03. What is the ratio of the Population (in %) of Ethiopia in 1985 to that in 1992?
Ensure brevity in your answer.  0.99. What is the ratio of the Population (in %) in Israel in 1985 to that in 1992?
Offer a terse response. 1.08. What is the ratio of the Population (in %) of Italy in 1985 to that in 1992?
Offer a terse response. 1.21. What is the ratio of the Population (in %) in Philippines in 1985 to that in 1992?
Ensure brevity in your answer.  1.03. What is the ratio of the Population (in %) in Israel in 1986 to that in 1987?
Ensure brevity in your answer.  1.01. What is the ratio of the Population (in %) of Italy in 1986 to that in 1987?
Your answer should be very brief. 1.03. What is the ratio of the Population (in %) of Israel in 1986 to that in 1988?
Your response must be concise. 1.02. What is the ratio of the Population (in %) in Italy in 1986 to that in 1988?
Provide a succinct answer. 1.06. What is the ratio of the Population (in %) in Ethiopia in 1986 to that in 1989?
Keep it short and to the point. 1. What is the ratio of the Population (in %) in Israel in 1986 to that in 1989?
Offer a very short reply. 1.03. What is the ratio of the Population (in %) of Italy in 1986 to that in 1989?
Your answer should be very brief. 1.1. What is the ratio of the Population (in %) of Philippines in 1986 to that in 1989?
Provide a succinct answer. 1.01. What is the ratio of the Population (in %) of Ethiopia in 1986 to that in 1990?
Keep it short and to the point. 1. What is the ratio of the Population (in %) of Israel in 1986 to that in 1990?
Your answer should be very brief. 1.04. What is the ratio of the Population (in %) of Italy in 1986 to that in 1990?
Give a very brief answer. 1.13. What is the ratio of the Population (in %) in Philippines in 1986 to that in 1990?
Give a very brief answer. 1.02. What is the ratio of the Population (in %) of Ethiopia in 1986 to that in 1991?
Your answer should be very brief. 1. What is the ratio of the Population (in %) in Israel in 1986 to that in 1991?
Keep it short and to the point. 1.06. What is the ratio of the Population (in %) of Italy in 1986 to that in 1991?
Provide a succinct answer. 1.15. What is the ratio of the Population (in %) of Philippines in 1986 to that in 1991?
Your answer should be very brief. 1.02. What is the ratio of the Population (in %) in Israel in 1986 to that in 1992?
Your response must be concise. 1.07. What is the ratio of the Population (in %) of Italy in 1986 to that in 1992?
Your answer should be compact. 1.18. What is the ratio of the Population (in %) of Philippines in 1986 to that in 1992?
Your response must be concise. 1.03. What is the ratio of the Population (in %) of Ethiopia in 1987 to that in 1988?
Your response must be concise. 1. What is the ratio of the Population (in %) of Israel in 1987 to that in 1988?
Your response must be concise. 1.01. What is the ratio of the Population (in %) in Italy in 1987 to that in 1988?
Provide a succinct answer. 1.03. What is the ratio of the Population (in %) of Israel in 1987 to that in 1989?
Your response must be concise. 1.02. What is the ratio of the Population (in %) in Italy in 1987 to that in 1989?
Make the answer very short. 1.06. What is the ratio of the Population (in %) in Philippines in 1987 to that in 1989?
Keep it short and to the point. 1.01. What is the ratio of the Population (in %) in Ethiopia in 1987 to that in 1990?
Your answer should be compact. 1. What is the ratio of the Population (in %) in Israel in 1987 to that in 1990?
Keep it short and to the point. 1.03. What is the ratio of the Population (in %) of Italy in 1987 to that in 1990?
Your answer should be compact. 1.09. What is the ratio of the Population (in %) of Philippines in 1987 to that in 1990?
Keep it short and to the point. 1.01. What is the ratio of the Population (in %) in Israel in 1987 to that in 1991?
Ensure brevity in your answer.  1.05. What is the ratio of the Population (in %) of Italy in 1987 to that in 1991?
Provide a short and direct response. 1.12. What is the ratio of the Population (in %) in Philippines in 1987 to that in 1991?
Make the answer very short. 1.02. What is the ratio of the Population (in %) of Israel in 1987 to that in 1992?
Your answer should be very brief. 1.06. What is the ratio of the Population (in %) of Italy in 1987 to that in 1992?
Provide a succinct answer. 1.14. What is the ratio of the Population (in %) in Philippines in 1987 to that in 1992?
Ensure brevity in your answer.  1.02. What is the ratio of the Population (in %) in Ethiopia in 1988 to that in 1989?
Offer a terse response. 1. What is the ratio of the Population (in %) of Israel in 1988 to that in 1989?
Ensure brevity in your answer.  1.01. What is the ratio of the Population (in %) of Italy in 1988 to that in 1989?
Your answer should be very brief. 1.03. What is the ratio of the Population (in %) in Ethiopia in 1988 to that in 1990?
Ensure brevity in your answer.  1. What is the ratio of the Population (in %) in Israel in 1988 to that in 1990?
Make the answer very short. 1.02. What is the ratio of the Population (in %) in Italy in 1988 to that in 1990?
Your response must be concise. 1.06. What is the ratio of the Population (in %) of Philippines in 1988 to that in 1990?
Provide a succinct answer. 1.01. What is the ratio of the Population (in %) of Ethiopia in 1988 to that in 1991?
Provide a short and direct response. 1. What is the ratio of the Population (in %) of Israel in 1988 to that in 1991?
Give a very brief answer. 1.04. What is the ratio of the Population (in %) of Italy in 1988 to that in 1991?
Provide a short and direct response. 1.08. What is the ratio of the Population (in %) of Philippines in 1988 to that in 1991?
Your response must be concise. 1.01. What is the ratio of the Population (in %) of Israel in 1988 to that in 1992?
Provide a short and direct response. 1.05. What is the ratio of the Population (in %) in Italy in 1988 to that in 1992?
Offer a terse response. 1.11. What is the ratio of the Population (in %) in Philippines in 1988 to that in 1992?
Your response must be concise. 1.02. What is the ratio of the Population (in %) in Israel in 1989 to that in 1990?
Provide a succinct answer. 1.01. What is the ratio of the Population (in %) of Italy in 1989 to that in 1990?
Give a very brief answer. 1.03. What is the ratio of the Population (in %) of Philippines in 1989 to that in 1990?
Your response must be concise. 1.01. What is the ratio of the Population (in %) of Italy in 1989 to that in 1991?
Give a very brief answer. 1.05. What is the ratio of the Population (in %) of Philippines in 1989 to that in 1991?
Give a very brief answer. 1.01. What is the ratio of the Population (in %) of Israel in 1989 to that in 1992?
Give a very brief answer. 1.04. What is the ratio of the Population (in %) in Italy in 1989 to that in 1992?
Keep it short and to the point. 1.07. What is the ratio of the Population (in %) of Philippines in 1989 to that in 1992?
Keep it short and to the point. 1.02. What is the ratio of the Population (in %) of Ethiopia in 1990 to that in 1991?
Your answer should be very brief. 1. What is the ratio of the Population (in %) in Israel in 1990 to that in 1991?
Your response must be concise. 1.01. What is the ratio of the Population (in %) of Italy in 1990 to that in 1991?
Make the answer very short. 1.02. What is the ratio of the Population (in %) in Ethiopia in 1990 to that in 1992?
Provide a short and direct response. 0.99. What is the ratio of the Population (in %) of Israel in 1990 to that in 1992?
Keep it short and to the point. 1.03. What is the ratio of the Population (in %) of Italy in 1990 to that in 1992?
Provide a succinct answer. 1.04. What is the ratio of the Population (in %) of Philippines in 1990 to that in 1992?
Give a very brief answer. 1.01. What is the ratio of the Population (in %) in Israel in 1991 to that in 1992?
Your answer should be compact. 1.02. What is the ratio of the Population (in %) in Italy in 1991 to that in 1992?
Offer a very short reply. 1.02. What is the difference between the highest and the second highest Population (in %) of Ethiopia?
Your answer should be compact. 0.12. What is the difference between the highest and the second highest Population (in %) of Israel?
Your response must be concise. 0.27. What is the difference between the highest and the second highest Population (in %) in Italy?
Give a very brief answer. 0.55. What is the difference between the highest and the second highest Population (in %) in Philippines?
Give a very brief answer. 0.19. What is the difference between the highest and the lowest Population (in %) in Ethiopia?
Ensure brevity in your answer.  0.47. What is the difference between the highest and the lowest Population (in %) in Israel?
Provide a succinct answer. 2.47. What is the difference between the highest and the lowest Population (in %) in Italy?
Your response must be concise. 3.35. What is the difference between the highest and the lowest Population (in %) of Philippines?
Provide a short and direct response. 1.32. 